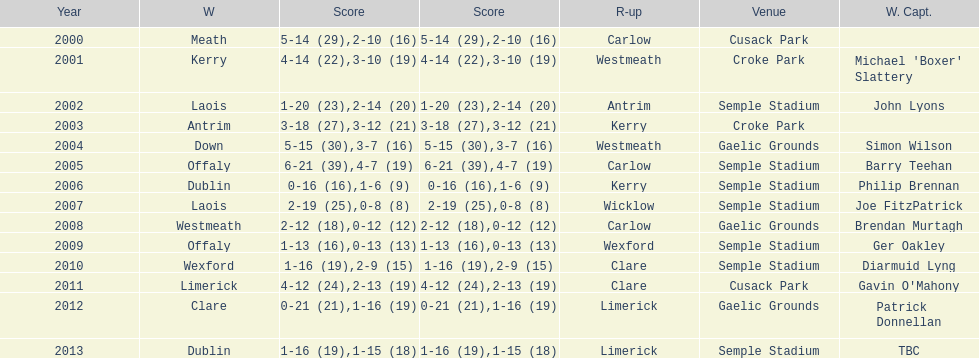Which team was the previous winner before dublin in 2013? Clare. 